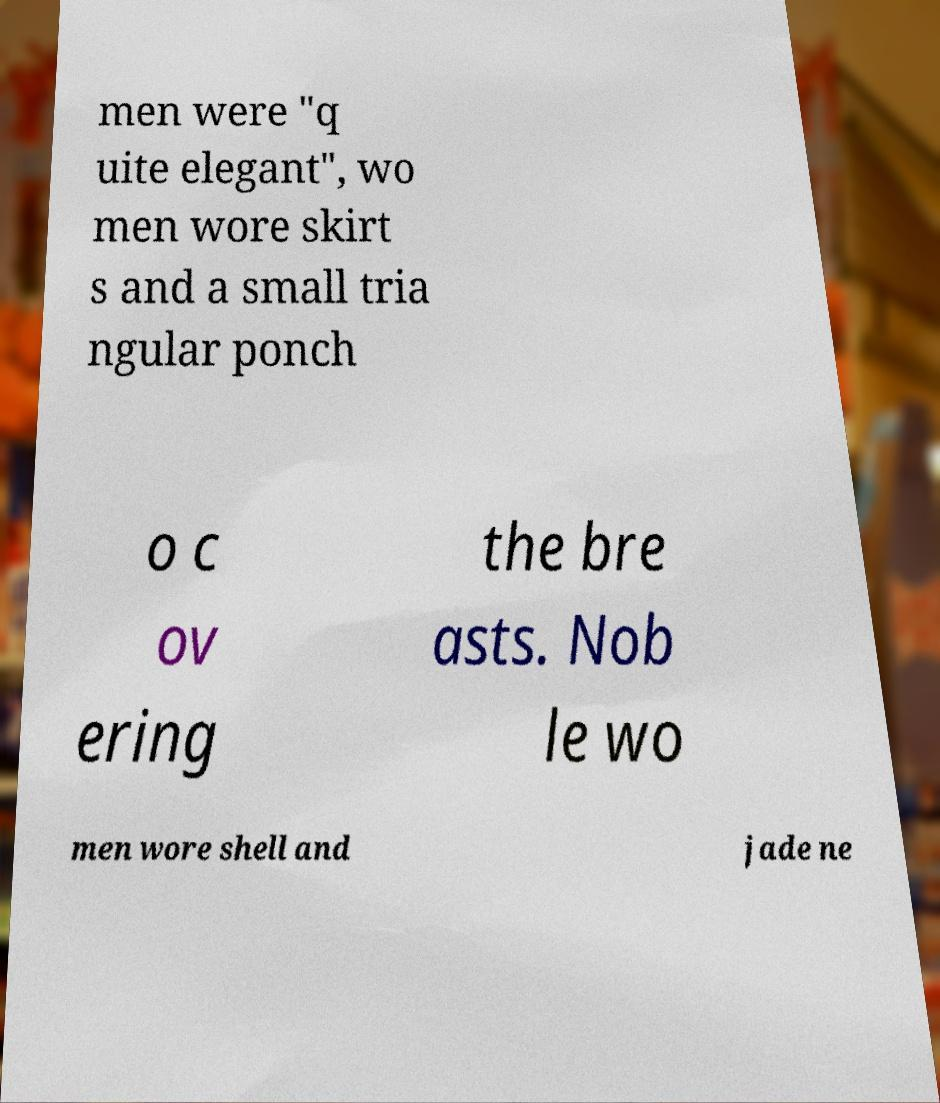Can you accurately transcribe the text from the provided image for me? men were "q uite elegant", wo men wore skirt s and a small tria ngular ponch o c ov ering the bre asts. Nob le wo men wore shell and jade ne 